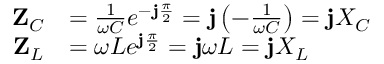Convert formula to latex. <formula><loc_0><loc_0><loc_500><loc_500>{ \begin{array} { r l } { Z _ { C } } & { = { \frac { 1 } { \omega C } } e ^ { - j { \frac { \pi } { 2 } } } = j \left ( { - { \frac { 1 } { \omega C } } } \right ) = j X _ { C } } \\ { Z _ { L } } & { = \omega L e ^ { j { \frac { \pi } { 2 } } } = j \omega L = j X _ { L } \quad } \end{array} }</formula> 